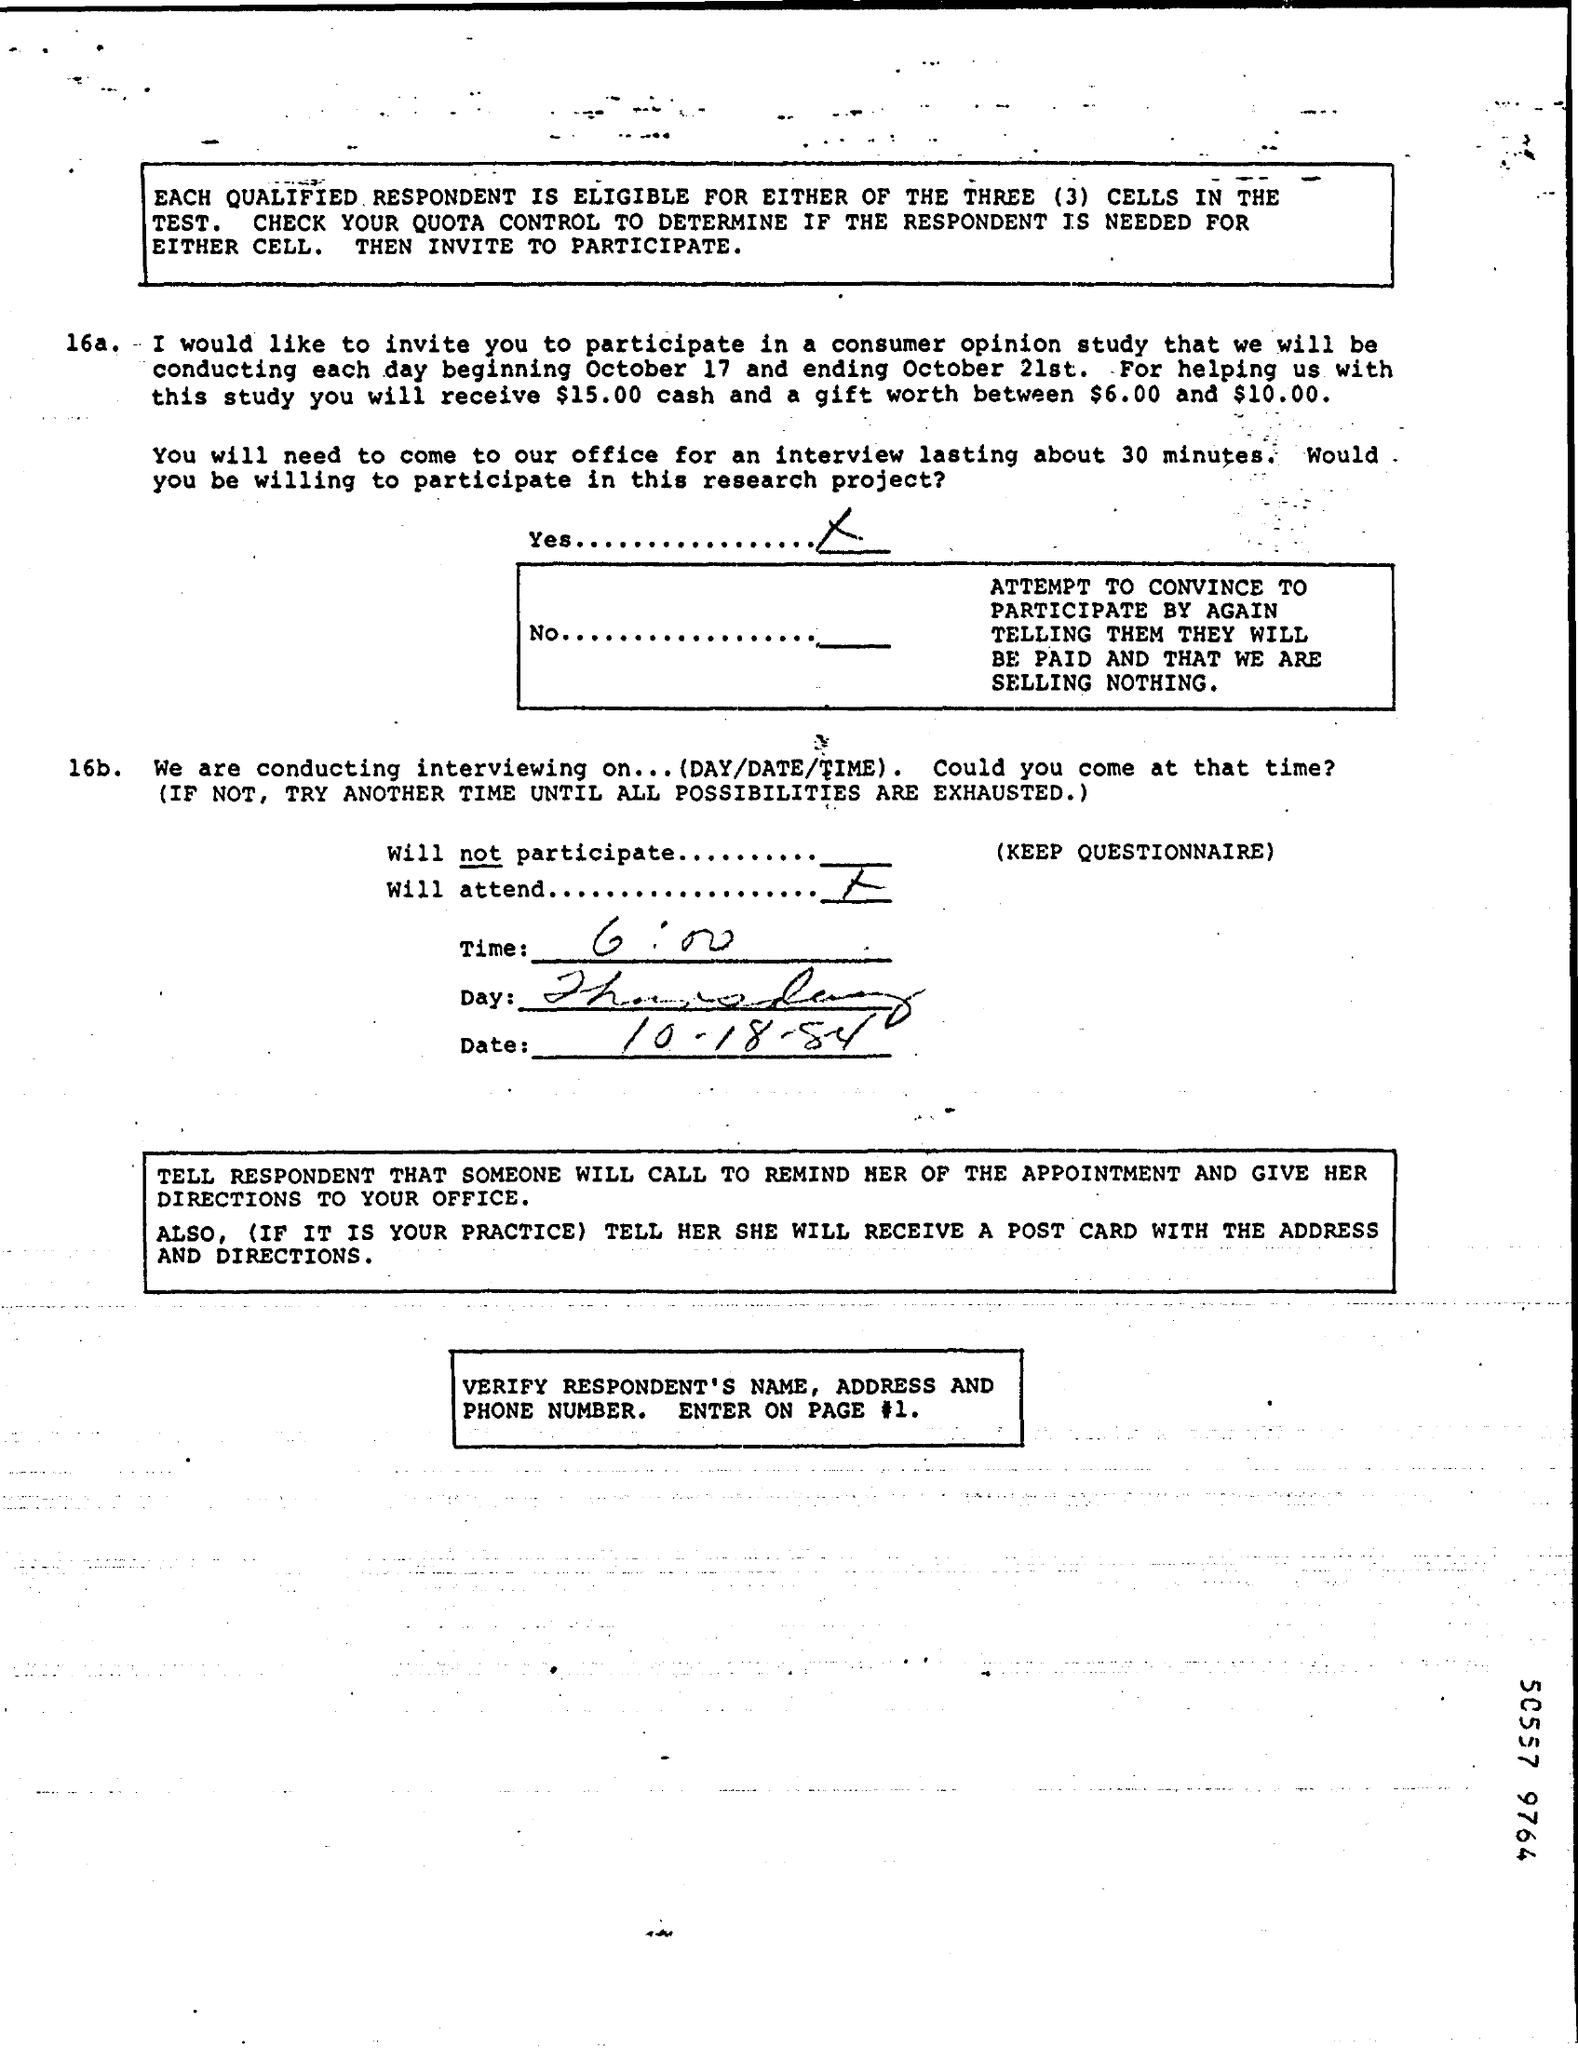What is the time mentioned in the document?
Your answer should be very brief. 6:00. What is the date mentioned in the document?
Give a very brief answer. 10.18.84. Which day is in the document?
Provide a short and direct response. Thursday. Which number is at the bottom?
Keep it short and to the point. 50557 9764. 